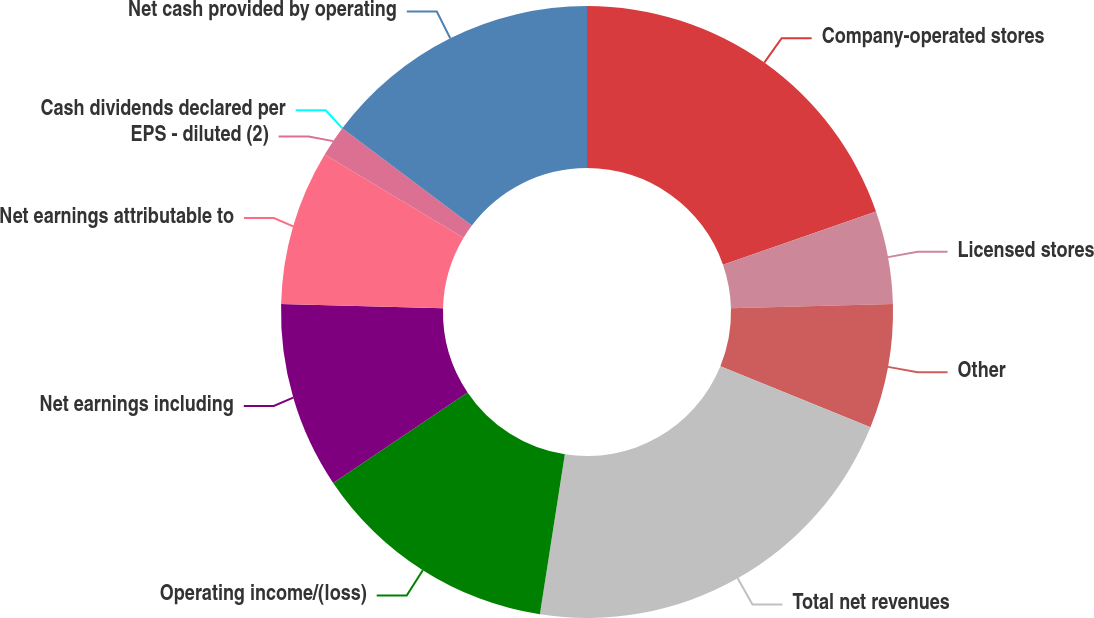Convert chart to OTSL. <chart><loc_0><loc_0><loc_500><loc_500><pie_chart><fcel>Company-operated stores<fcel>Licensed stores<fcel>Other<fcel>Total net revenues<fcel>Operating income/(loss)<fcel>Net earnings including<fcel>Net earnings attributable to<fcel>EPS - diluted (2)<fcel>Cash dividends declared per<fcel>Net cash provided by operating<nl><fcel>19.67%<fcel>4.92%<fcel>6.56%<fcel>21.31%<fcel>13.11%<fcel>9.84%<fcel>8.2%<fcel>1.64%<fcel>0.0%<fcel>14.75%<nl></chart> 